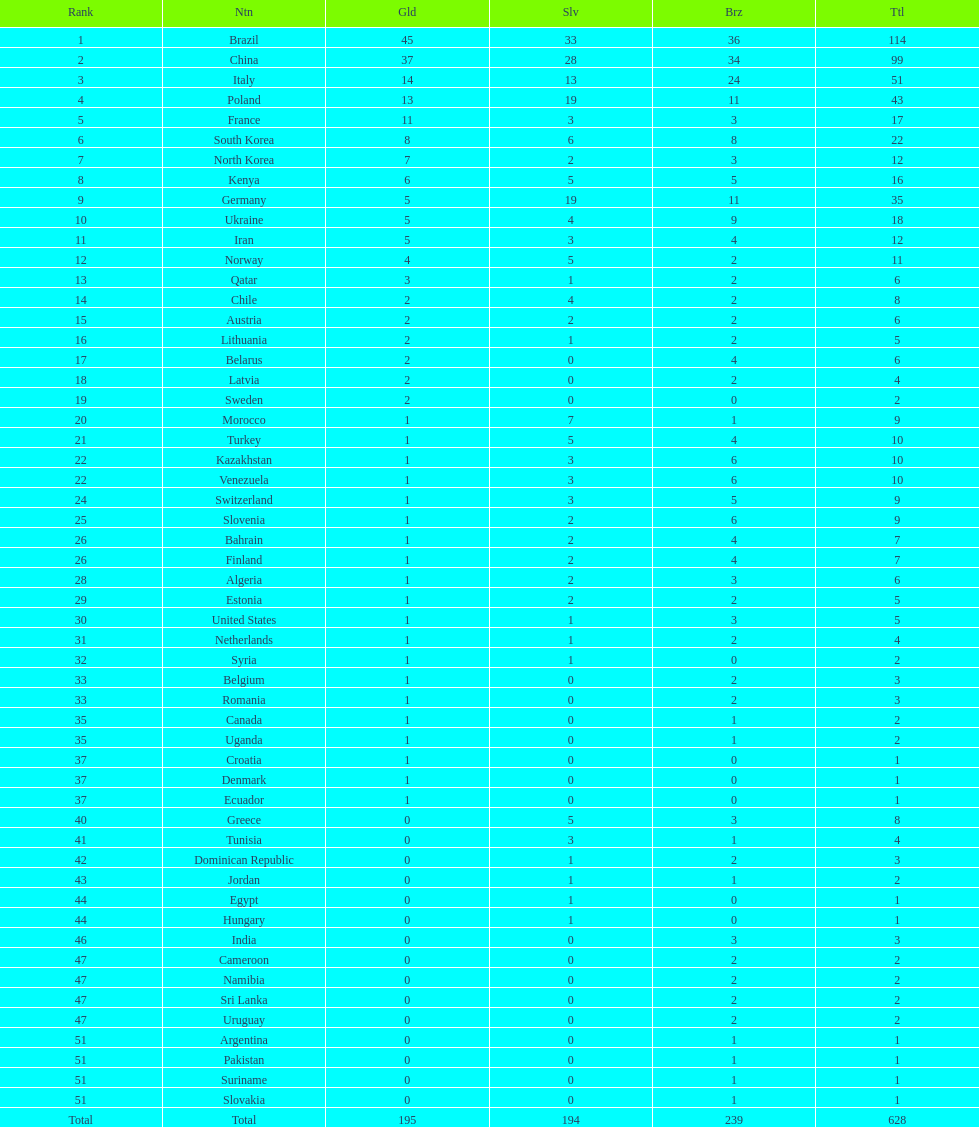Which nation obtained the greatest amount of gold medals? Brazil. 